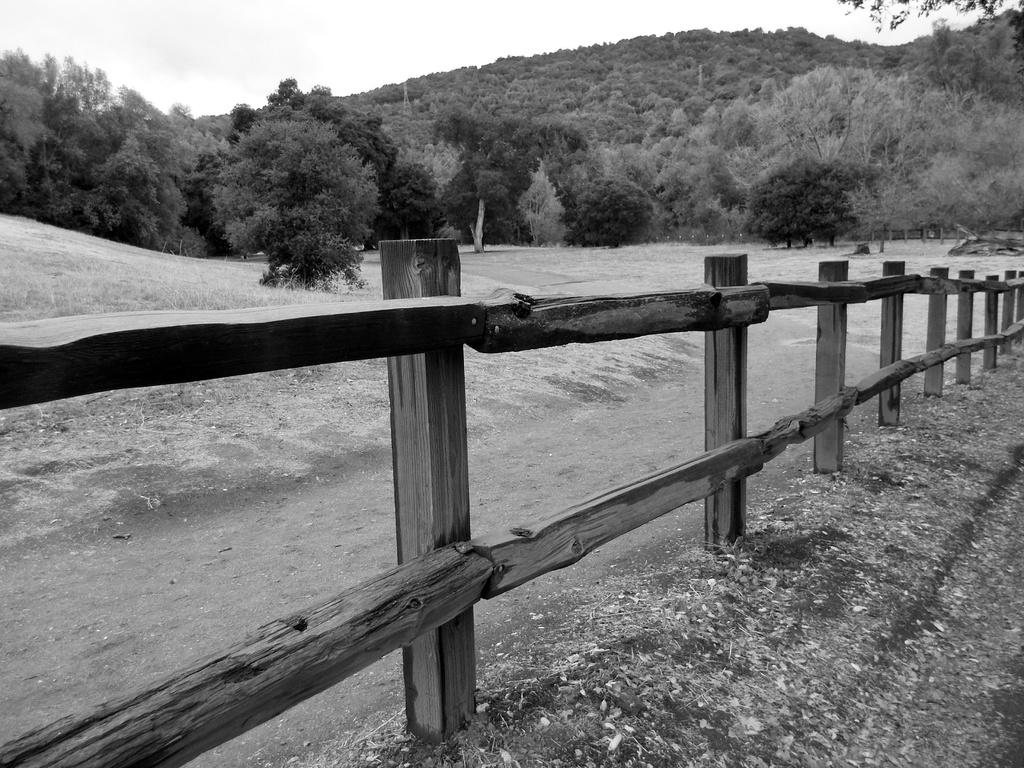What type of barrier is located at the front of the image? There is a wooden fence in the front of the image. What can be seen in the distance in the image? There are trees in the background of the image. What type of appliance is hanging from the branches of the trees in the image? There are no appliances visible in the image; it only features a wooden fence and trees. 